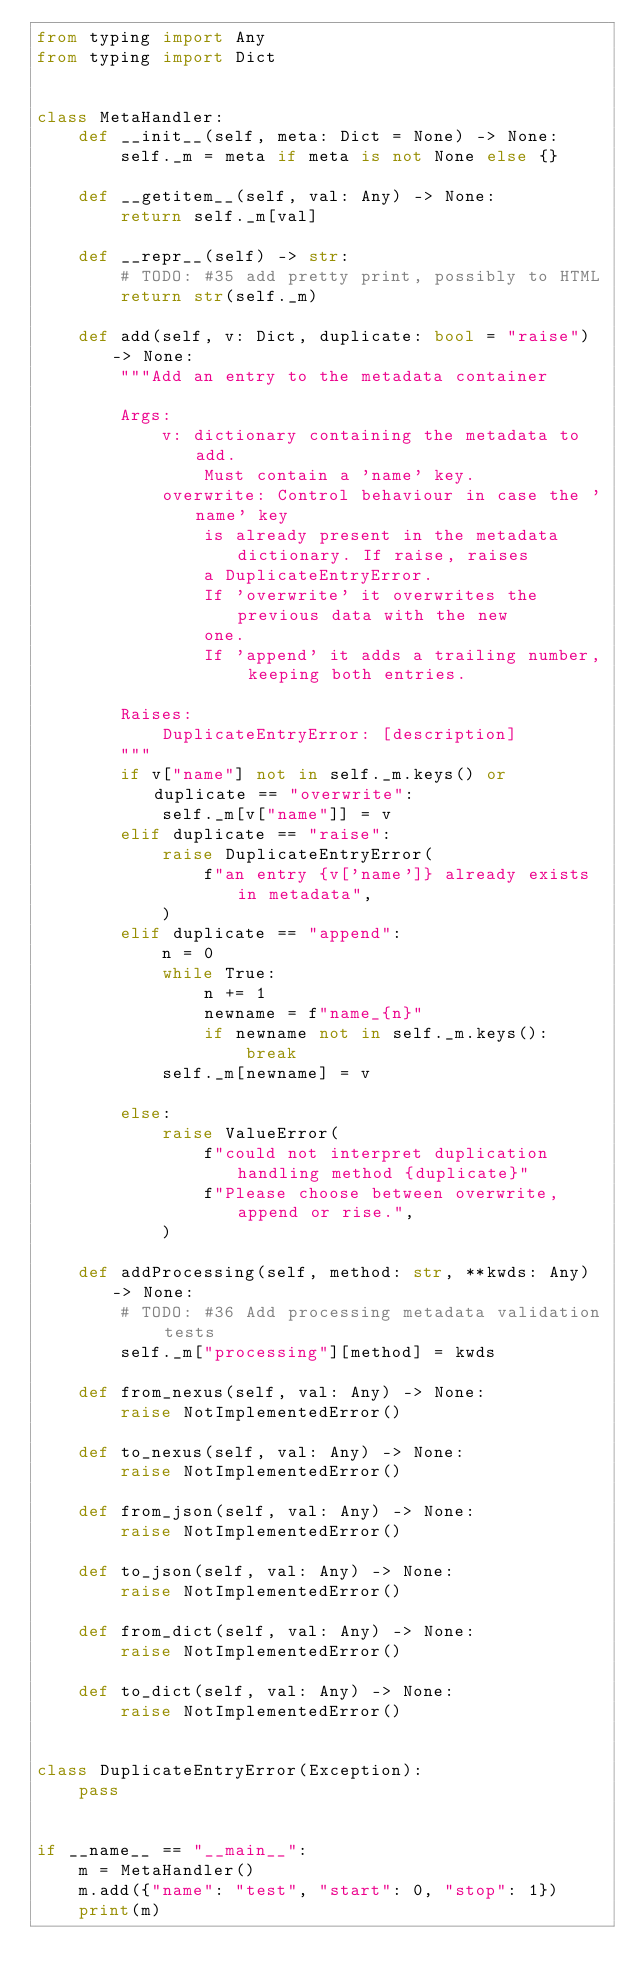Convert code to text. <code><loc_0><loc_0><loc_500><loc_500><_Python_>from typing import Any
from typing import Dict


class MetaHandler:
    def __init__(self, meta: Dict = None) -> None:
        self._m = meta if meta is not None else {}

    def __getitem__(self, val: Any) -> None:
        return self._m[val]

    def __repr__(self) -> str:
        # TODO: #35 add pretty print, possibly to HTML
        return str(self._m)

    def add(self, v: Dict, duplicate: bool = "raise") -> None:
        """Add an entry to the metadata container

        Args:
            v: dictionary containing the metadata to add.
                Must contain a 'name' key.
            overwrite: Control behaviour in case the 'name' key
                is already present in the metadata dictionary. If raise, raises
                a DuplicateEntryError.
                If 'overwrite' it overwrites the previous data with the new
                one.
                If 'append' it adds a trailing number, keeping both entries.

        Raises:
            DuplicateEntryError: [description]
        """
        if v["name"] not in self._m.keys() or duplicate == "overwrite":
            self._m[v["name"]] = v
        elif duplicate == "raise":
            raise DuplicateEntryError(
                f"an entry {v['name']} already exists in metadata",
            )
        elif duplicate == "append":
            n = 0
            while True:
                n += 1
                newname = f"name_{n}"
                if newname not in self._m.keys():
                    break
            self._m[newname] = v

        else:
            raise ValueError(
                f"could not interpret duplication handling method {duplicate}"
                f"Please choose between overwrite,append or rise.",
            )

    def addProcessing(self, method: str, **kwds: Any) -> None:
        # TODO: #36 Add processing metadata validation tests
        self._m["processing"][method] = kwds

    def from_nexus(self, val: Any) -> None:
        raise NotImplementedError()

    def to_nexus(self, val: Any) -> None:
        raise NotImplementedError()

    def from_json(self, val: Any) -> None:
        raise NotImplementedError()

    def to_json(self, val: Any) -> None:
        raise NotImplementedError()

    def from_dict(self, val: Any) -> None:
        raise NotImplementedError()

    def to_dict(self, val: Any) -> None:
        raise NotImplementedError()


class DuplicateEntryError(Exception):
    pass


if __name__ == "__main__":
    m = MetaHandler()
    m.add({"name": "test", "start": 0, "stop": 1})
    print(m)
</code> 